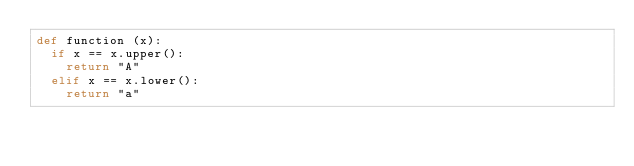Convert code to text. <code><loc_0><loc_0><loc_500><loc_500><_Python_>def function (x):
  if x == x.upper():
    return "A"
  elif x == x.lower():
    return "a"
  </code> 